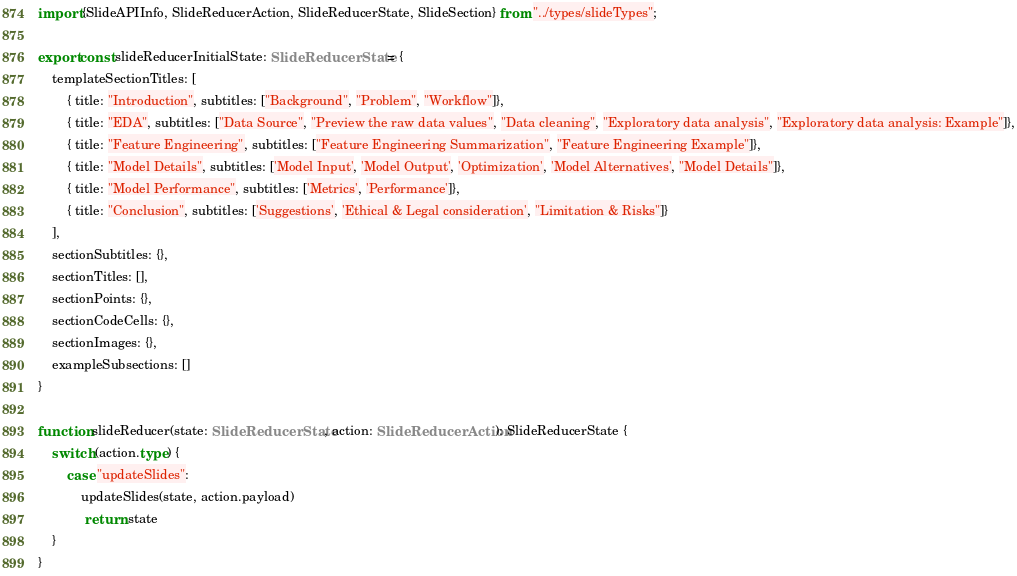<code> <loc_0><loc_0><loc_500><loc_500><_TypeScript_>import {SlideAPIInfo, SlideReducerAction, SlideReducerState, SlideSection} from "../types/slideTypes";

export const slideReducerInitialState: SlideReducerState = {
    templateSectionTitles: [
        { title: "Introduction", subtitles: ["Background", "Problem", "Workflow"]},
        { title: "EDA", subtitles: ["Data Source", "Preview the raw data values", "Data cleaning", "Exploratory data analysis", "Exploratory data analysis: Example"]},
        { title: "Feature Engineering", subtitles: ["Feature Engineering Summarization", "Feature Engineering Example"]},
        { title: "Model Details", subtitles: ['Model Input', 'Model Output', 'Optimization', 'Model Alternatives', "Model Details"]},
        { title: "Model Performance", subtitles: ['Metrics', 'Performance']},
        { title: "Conclusion", subtitles: ['Suggestions', 'Ethical & Legal consideration', "Limitation & Risks"]}
    ],
    sectionSubtitles: {},
    sectionTitles: [],
    sectionPoints: {},
    sectionCodeCells: {},
    sectionImages: {},
    exampleSubsections: []
}

function slideReducer(state: SlideReducerState, action: SlideReducerAction): SlideReducerState {
    switch (action.type) {
        case "updateSlides":
            updateSlides(state, action.payload)
             return state
    }
}
</code> 